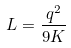<formula> <loc_0><loc_0><loc_500><loc_500>L = \frac { q ^ { 2 } } { 9 K }</formula> 